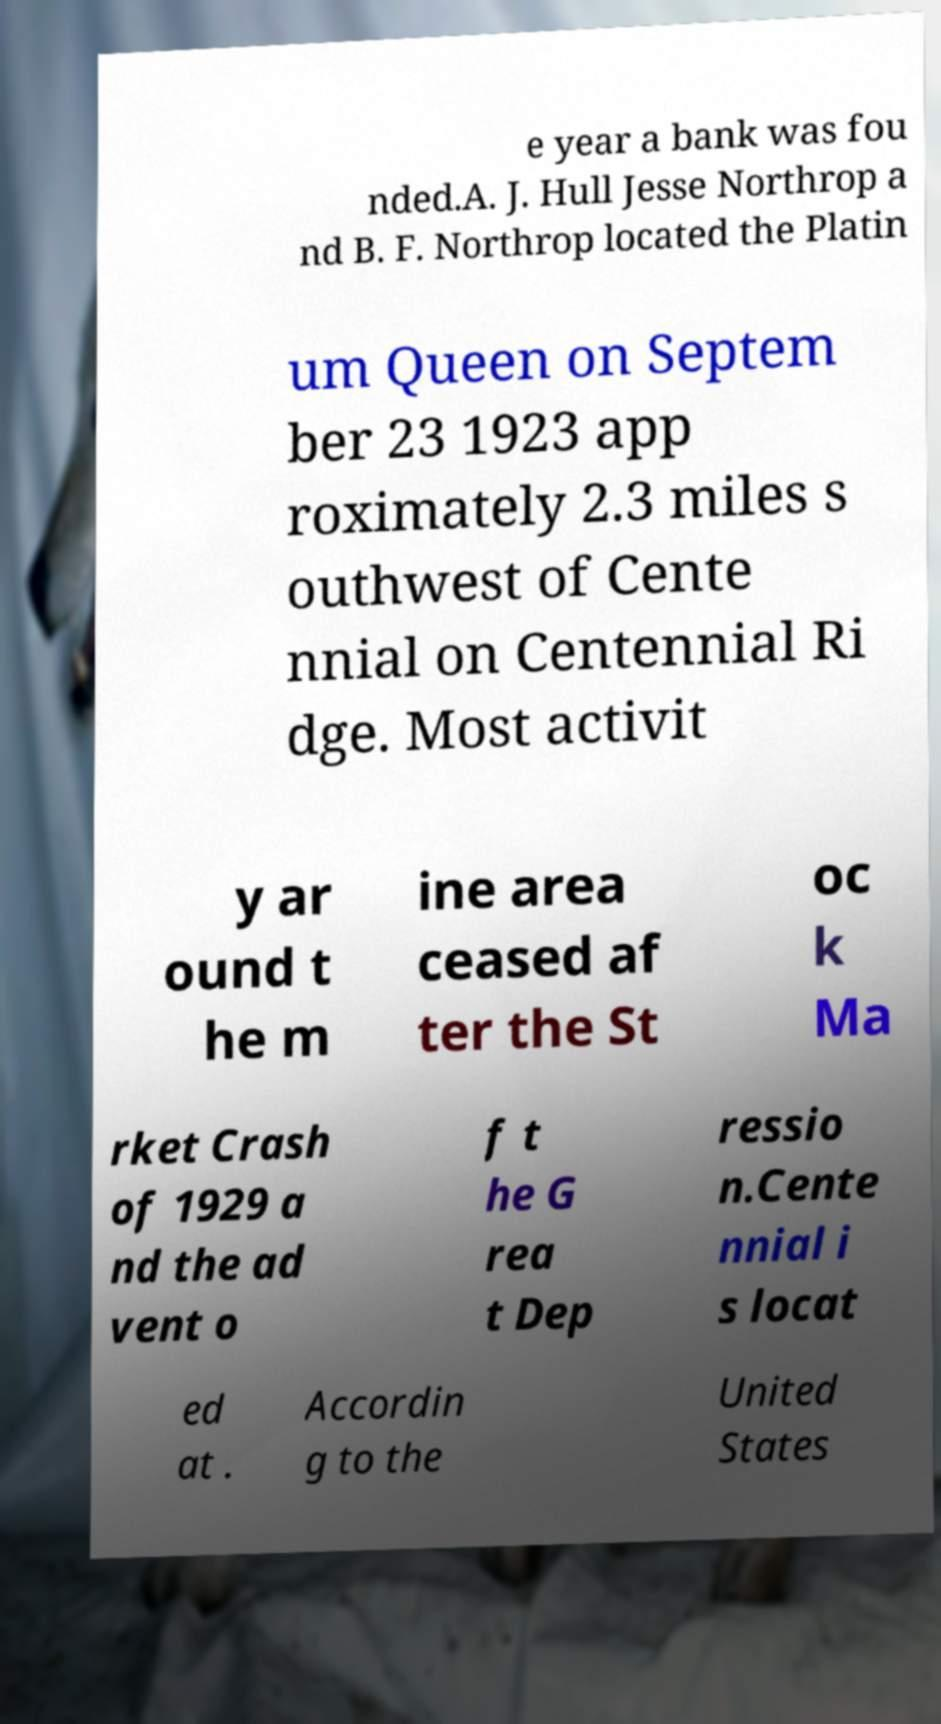Could you extract and type out the text from this image? e year a bank was fou nded.A. J. Hull Jesse Northrop a nd B. F. Northrop located the Platin um Queen on Septem ber 23 1923 app roximately 2.3 miles s outhwest of Cente nnial on Centennial Ri dge. Most activit y ar ound t he m ine area ceased af ter the St oc k Ma rket Crash of 1929 a nd the ad vent o f t he G rea t Dep ressio n.Cente nnial i s locat ed at . Accordin g to the United States 